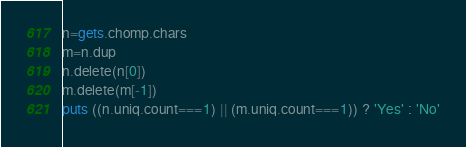Convert code to text. <code><loc_0><loc_0><loc_500><loc_500><_Ruby_>n=gets.chomp.chars
m=n.dup
n.delete(n[0])
m.delete(m[-1])
puts ((n.uniq.count===1) || (m.uniq.count===1)) ? 'Yes' : 'No'</code> 